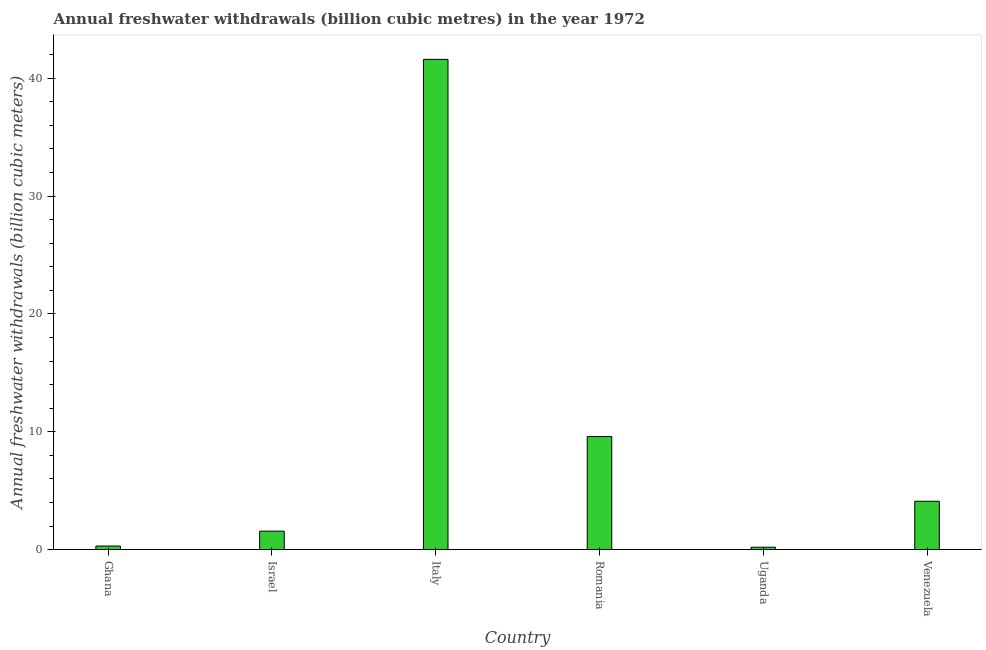Does the graph contain any zero values?
Make the answer very short. No. Does the graph contain grids?
Keep it short and to the point. No. What is the title of the graph?
Provide a short and direct response. Annual freshwater withdrawals (billion cubic metres) in the year 1972. What is the label or title of the X-axis?
Your answer should be very brief. Country. What is the label or title of the Y-axis?
Give a very brief answer. Annual freshwater withdrawals (billion cubic meters). What is the annual freshwater withdrawals in Ghana?
Offer a terse response. 0.3. Across all countries, what is the maximum annual freshwater withdrawals?
Offer a terse response. 41.6. In which country was the annual freshwater withdrawals maximum?
Your response must be concise. Italy. In which country was the annual freshwater withdrawals minimum?
Make the answer very short. Uganda. What is the sum of the annual freshwater withdrawals?
Keep it short and to the point. 57.35. What is the difference between the annual freshwater withdrawals in Israel and Venezuela?
Ensure brevity in your answer.  -2.54. What is the average annual freshwater withdrawals per country?
Keep it short and to the point. 9.56. What is the median annual freshwater withdrawals?
Provide a short and direct response. 2.83. In how many countries, is the annual freshwater withdrawals greater than 8 billion cubic meters?
Keep it short and to the point. 2. What is the ratio of the annual freshwater withdrawals in Uganda to that in Venezuela?
Give a very brief answer. 0.05. Is the annual freshwater withdrawals in Ghana less than that in Uganda?
Ensure brevity in your answer.  No. Is the difference between the annual freshwater withdrawals in Ghana and Romania greater than the difference between any two countries?
Give a very brief answer. No. What is the difference between the highest and the second highest annual freshwater withdrawals?
Offer a very short reply. 32.01. What is the difference between the highest and the lowest annual freshwater withdrawals?
Your answer should be compact. 41.4. In how many countries, is the annual freshwater withdrawals greater than the average annual freshwater withdrawals taken over all countries?
Offer a terse response. 2. How many countries are there in the graph?
Your answer should be very brief. 6. What is the difference between two consecutive major ticks on the Y-axis?
Make the answer very short. 10. What is the Annual freshwater withdrawals (billion cubic meters) in Ghana?
Your answer should be very brief. 0.3. What is the Annual freshwater withdrawals (billion cubic meters) of Israel?
Provide a succinct answer. 1.56. What is the Annual freshwater withdrawals (billion cubic meters) of Italy?
Ensure brevity in your answer.  41.6. What is the Annual freshwater withdrawals (billion cubic meters) in Romania?
Your response must be concise. 9.59. What is the difference between the Annual freshwater withdrawals (billion cubic meters) in Ghana and Israel?
Make the answer very short. -1.26. What is the difference between the Annual freshwater withdrawals (billion cubic meters) in Ghana and Italy?
Ensure brevity in your answer.  -41.3. What is the difference between the Annual freshwater withdrawals (billion cubic meters) in Ghana and Romania?
Provide a short and direct response. -9.29. What is the difference between the Annual freshwater withdrawals (billion cubic meters) in Ghana and Uganda?
Your response must be concise. 0.1. What is the difference between the Annual freshwater withdrawals (billion cubic meters) in Ghana and Venezuela?
Offer a terse response. -3.8. What is the difference between the Annual freshwater withdrawals (billion cubic meters) in Israel and Italy?
Provide a succinct answer. -40.04. What is the difference between the Annual freshwater withdrawals (billion cubic meters) in Israel and Romania?
Keep it short and to the point. -8.03. What is the difference between the Annual freshwater withdrawals (billion cubic meters) in Israel and Uganda?
Keep it short and to the point. 1.36. What is the difference between the Annual freshwater withdrawals (billion cubic meters) in Israel and Venezuela?
Provide a short and direct response. -2.54. What is the difference between the Annual freshwater withdrawals (billion cubic meters) in Italy and Romania?
Give a very brief answer. 32.01. What is the difference between the Annual freshwater withdrawals (billion cubic meters) in Italy and Uganda?
Give a very brief answer. 41.4. What is the difference between the Annual freshwater withdrawals (billion cubic meters) in Italy and Venezuela?
Offer a terse response. 37.5. What is the difference between the Annual freshwater withdrawals (billion cubic meters) in Romania and Uganda?
Your response must be concise. 9.39. What is the difference between the Annual freshwater withdrawals (billion cubic meters) in Romania and Venezuela?
Provide a short and direct response. 5.49. What is the difference between the Annual freshwater withdrawals (billion cubic meters) in Uganda and Venezuela?
Your response must be concise. -3.9. What is the ratio of the Annual freshwater withdrawals (billion cubic meters) in Ghana to that in Israel?
Provide a succinct answer. 0.19. What is the ratio of the Annual freshwater withdrawals (billion cubic meters) in Ghana to that in Italy?
Your answer should be compact. 0.01. What is the ratio of the Annual freshwater withdrawals (billion cubic meters) in Ghana to that in Romania?
Keep it short and to the point. 0.03. What is the ratio of the Annual freshwater withdrawals (billion cubic meters) in Ghana to that in Venezuela?
Give a very brief answer. 0.07. What is the ratio of the Annual freshwater withdrawals (billion cubic meters) in Israel to that in Italy?
Provide a short and direct response. 0.04. What is the ratio of the Annual freshwater withdrawals (billion cubic meters) in Israel to that in Romania?
Your answer should be very brief. 0.16. What is the ratio of the Annual freshwater withdrawals (billion cubic meters) in Israel to that in Uganda?
Your response must be concise. 7.82. What is the ratio of the Annual freshwater withdrawals (billion cubic meters) in Israel to that in Venezuela?
Your answer should be compact. 0.38. What is the ratio of the Annual freshwater withdrawals (billion cubic meters) in Italy to that in Romania?
Your answer should be compact. 4.34. What is the ratio of the Annual freshwater withdrawals (billion cubic meters) in Italy to that in Uganda?
Provide a short and direct response. 208. What is the ratio of the Annual freshwater withdrawals (billion cubic meters) in Italy to that in Venezuela?
Give a very brief answer. 10.15. What is the ratio of the Annual freshwater withdrawals (billion cubic meters) in Romania to that in Uganda?
Offer a very short reply. 47.95. What is the ratio of the Annual freshwater withdrawals (billion cubic meters) in Romania to that in Venezuela?
Provide a short and direct response. 2.34. What is the ratio of the Annual freshwater withdrawals (billion cubic meters) in Uganda to that in Venezuela?
Make the answer very short. 0.05. 